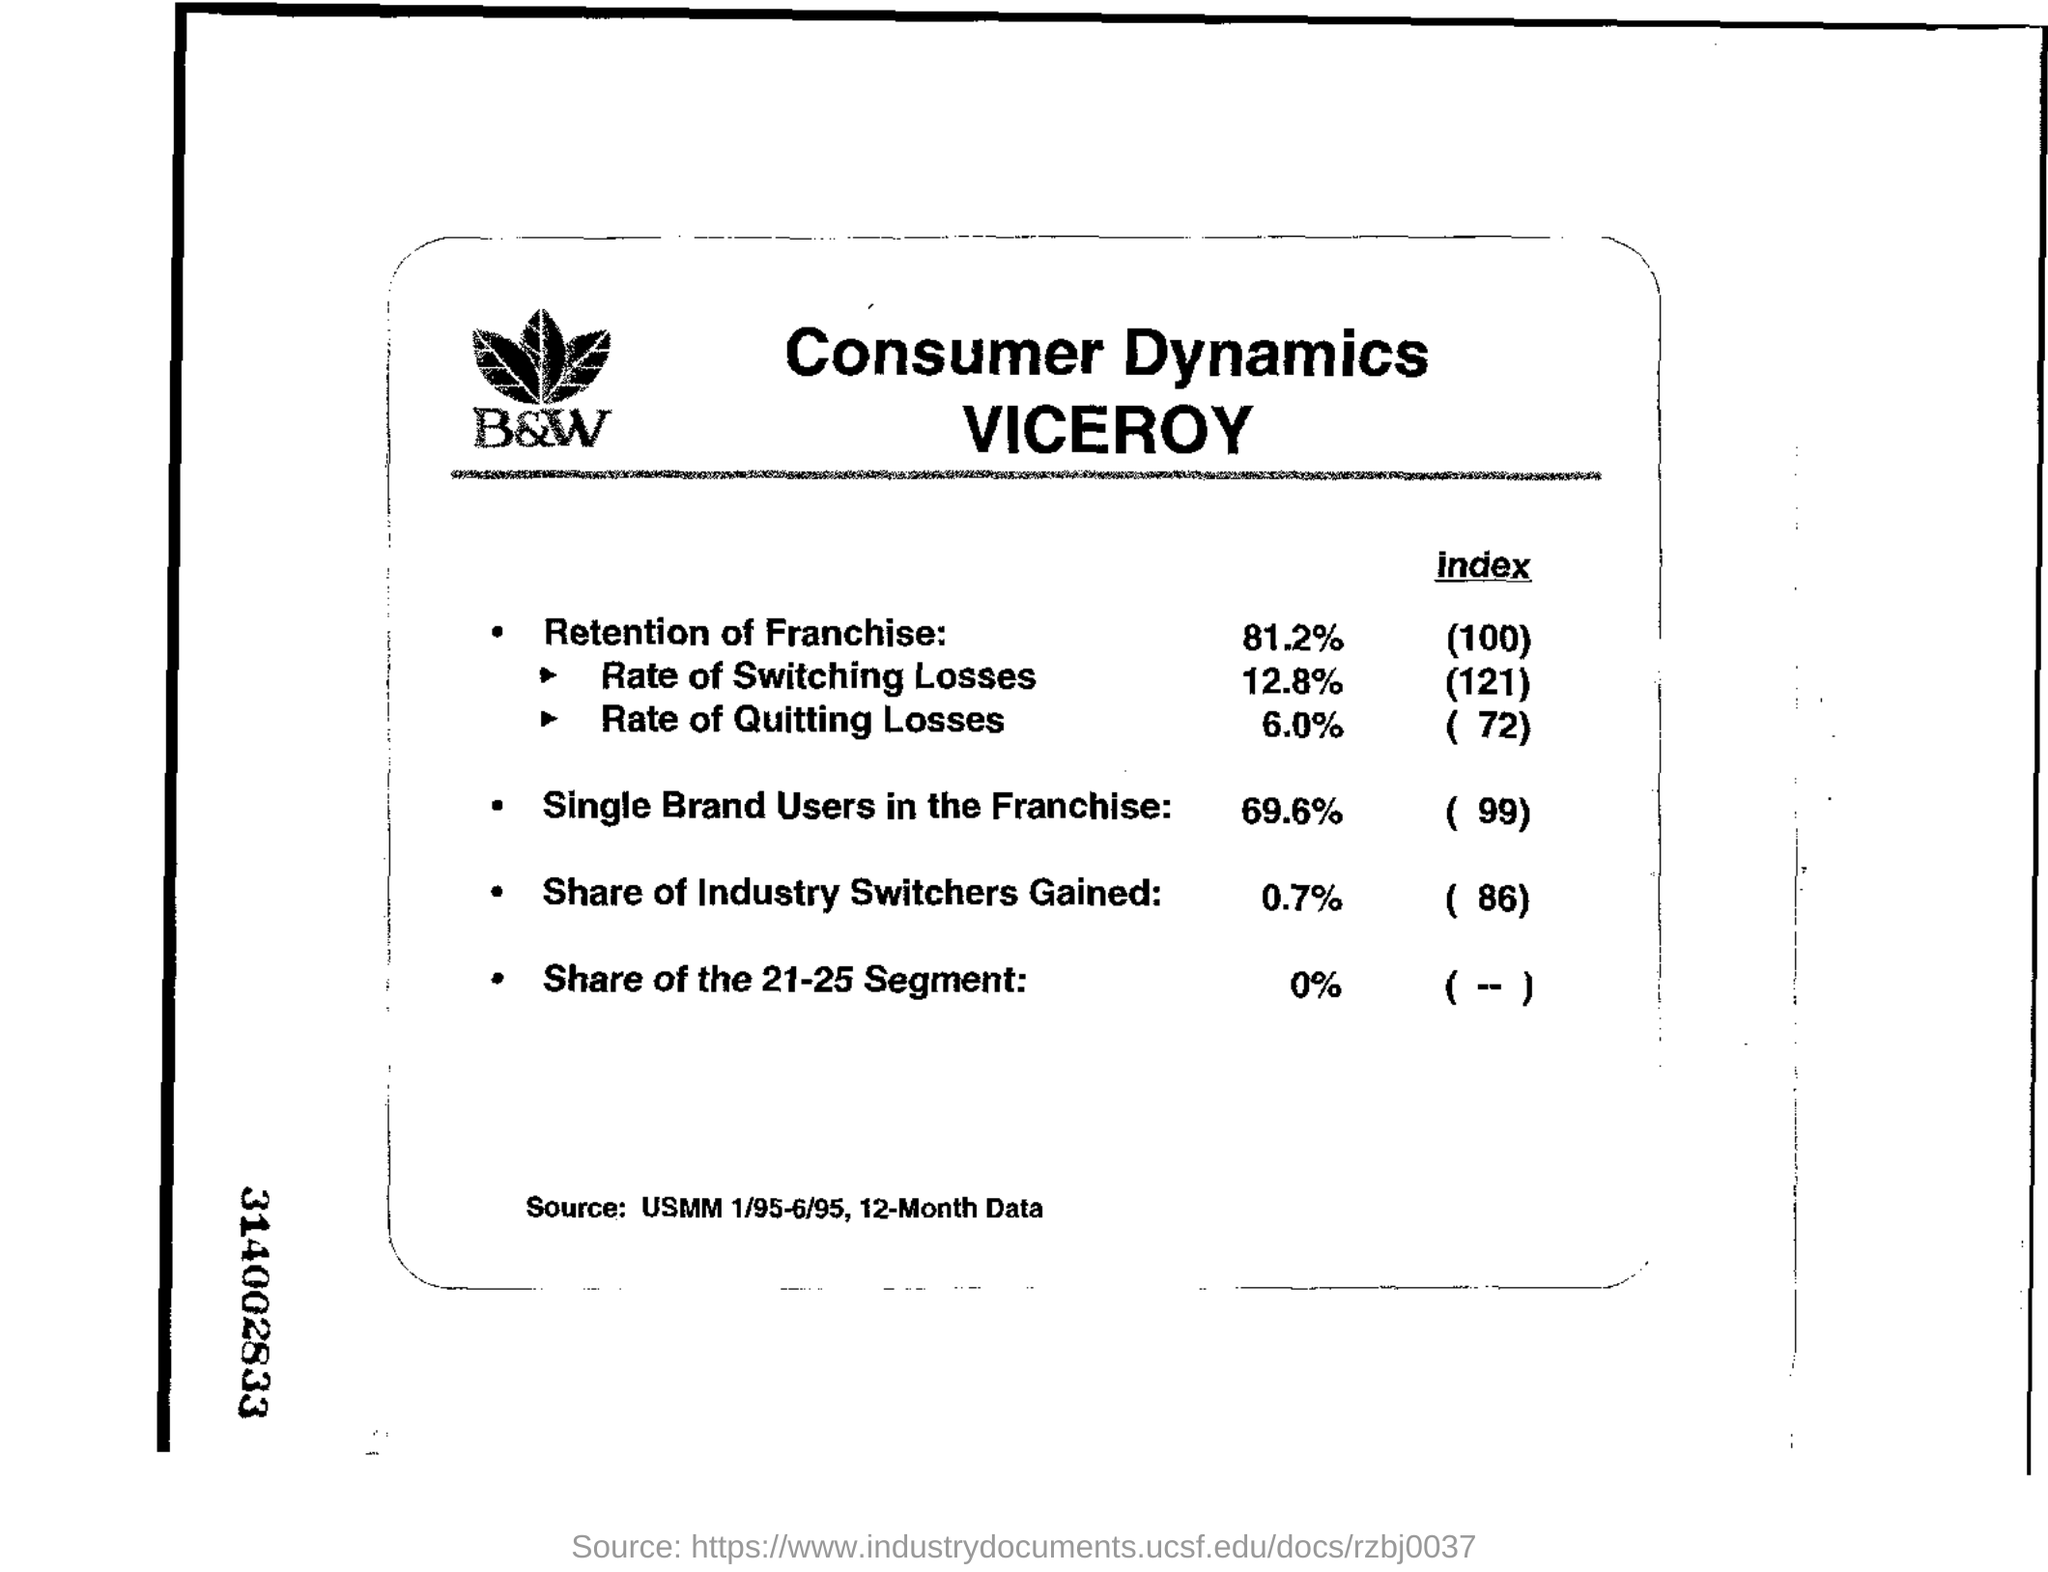Highlight a few significant elements in this photo. The 21-25 segment is not mentioned in the provided information. The retention of franchise refers to the percentage of franchises that choose to renew their contract for another term. The name of the company is B&W. 